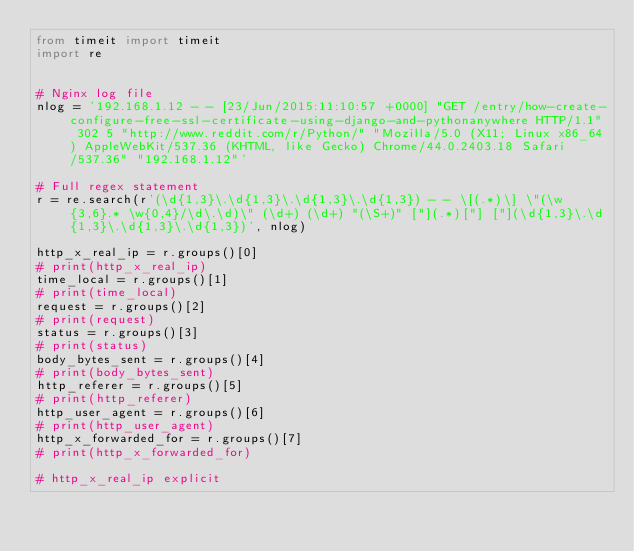Convert code to text. <code><loc_0><loc_0><loc_500><loc_500><_Python_>from timeit import timeit
import re


# Nginx log file
nlog = '192.168.1.12 - - [23/Jun/2015:11:10:57 +0000] "GET /entry/how-create-configure-free-ssl-certificate-using-django-and-pythonanywhere HTTP/1.1" 302 5 "http://www.reddit.com/r/Python/" "Mozilla/5.0 (X11; Linux x86_64) AppleWebKit/537.36 (KHTML, like Gecko) Chrome/44.0.2403.18 Safari/537.36" "192.168.1.12"'

# Full regex statement
r = re.search(r'(\d{1,3}\.\d{1,3}\.\d{1,3}\.\d{1,3}) - - \[(.*)\] \"(\w{3,6}.* \w{0,4}/\d\.\d)\" (\d+) (\d+) "(\S+)" ["](.*)["] ["](\d{1,3}\.\d{1,3}\.\d{1,3}\.\d{1,3})', nlog)

http_x_real_ip = r.groups()[0]
# print(http_x_real_ip)
time_local = r.groups()[1]
# print(time_local)
request = r.groups()[2]
# print(request)
status = r.groups()[3]
# print(status)
body_bytes_sent = r.groups()[4]
# print(body_bytes_sent)
http_referer = r.groups()[5]
# print(http_referer)
http_user_agent = r.groups()[6]
# print(http_user_agent)
http_x_forwarded_for = r.groups()[7]
# print(http_x_forwarded_for)

# http_x_real_ip explicit</code> 